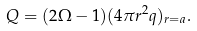Convert formula to latex. <formula><loc_0><loc_0><loc_500><loc_500>Q = ( 2 \Omega - 1 ) ( 4 \pi r ^ { 2 } q ) _ { r = a } .</formula> 